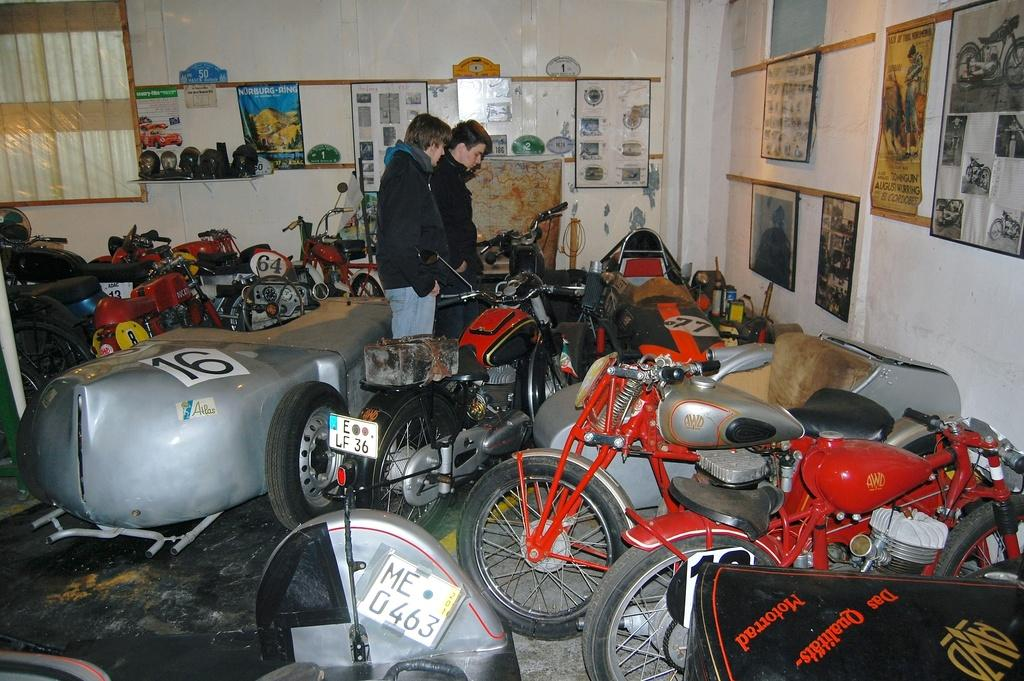How many men are present in the image? There are two men standing in the image. What can be seen on the floor in the image? There are bikes on the floor in the image. What is on the wall in the image? There are frames and boards on the wall in the image. Is there any source of natural light in the image? Yes, there is a window in the image. Can you describe any objects visible in the image? There are objects visible in the image, but their specific nature is not mentioned in the provided facts. What type of wound can be seen on the donkey in the image? There is no donkey present in the image, so no wound can be observed. 